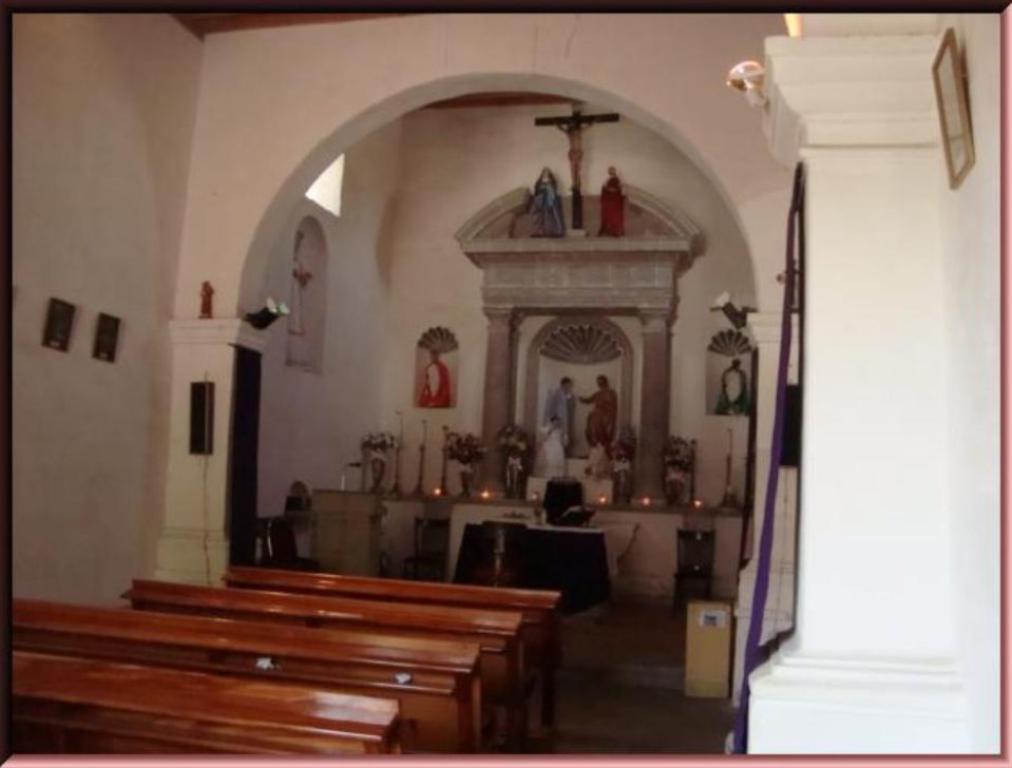How would you summarize this image in a sentence or two? This is the inside view of a church. These are the benches. This is the wall. Here we can see a podium with the mike. And these are the flower bouquets. 